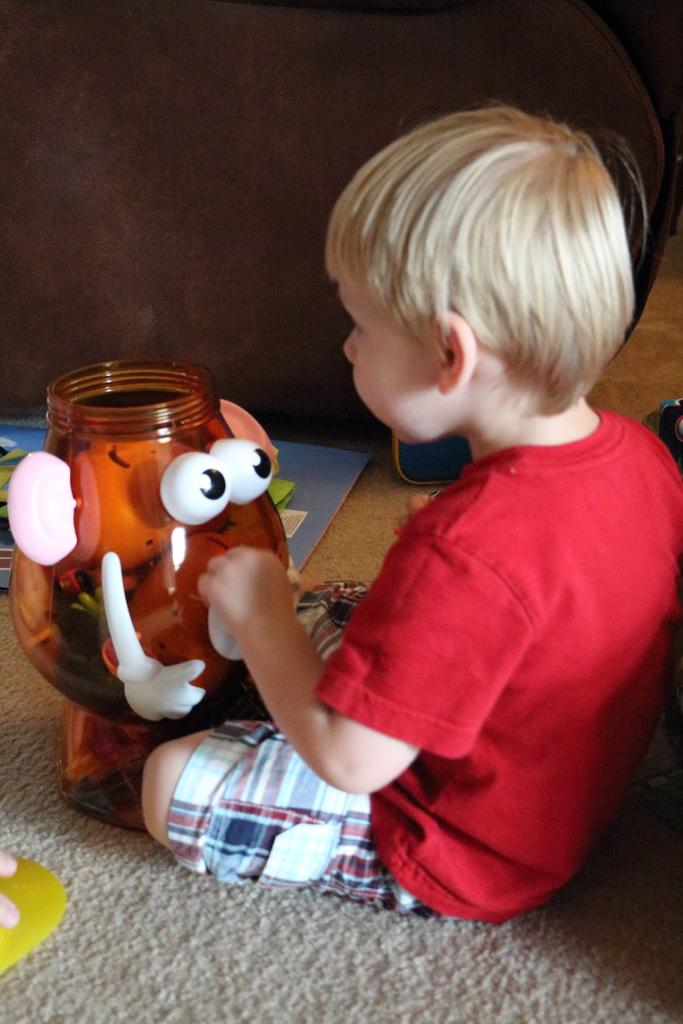Who is the main subject in the image? There is a boy in the image. What is the boy doing in the image? The boy is sitting on the floor. What can be seen in front of the boy? There are toys in front of the boy. What type of spoon is the boy using to dig into the earth in the image? There is no spoon or digging activity present in the image; the boy is sitting with toys in front of him. 